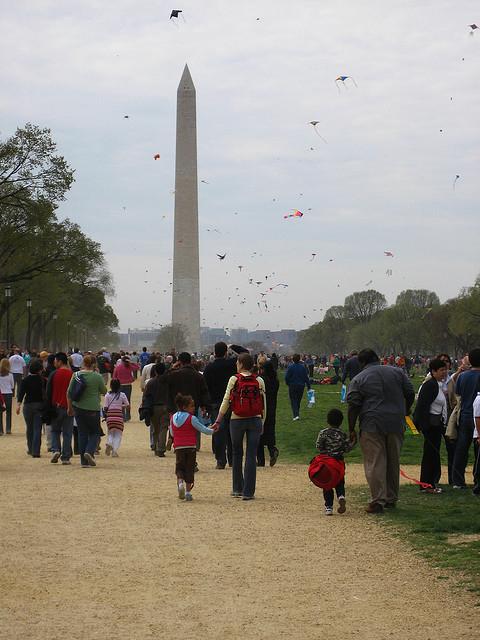Is this in Washington DC?
Concise answer only. Yes. What is the name of the tower?
Answer briefly. Washington monument. What are all of the things in the sky?
Be succinct. Kites. 